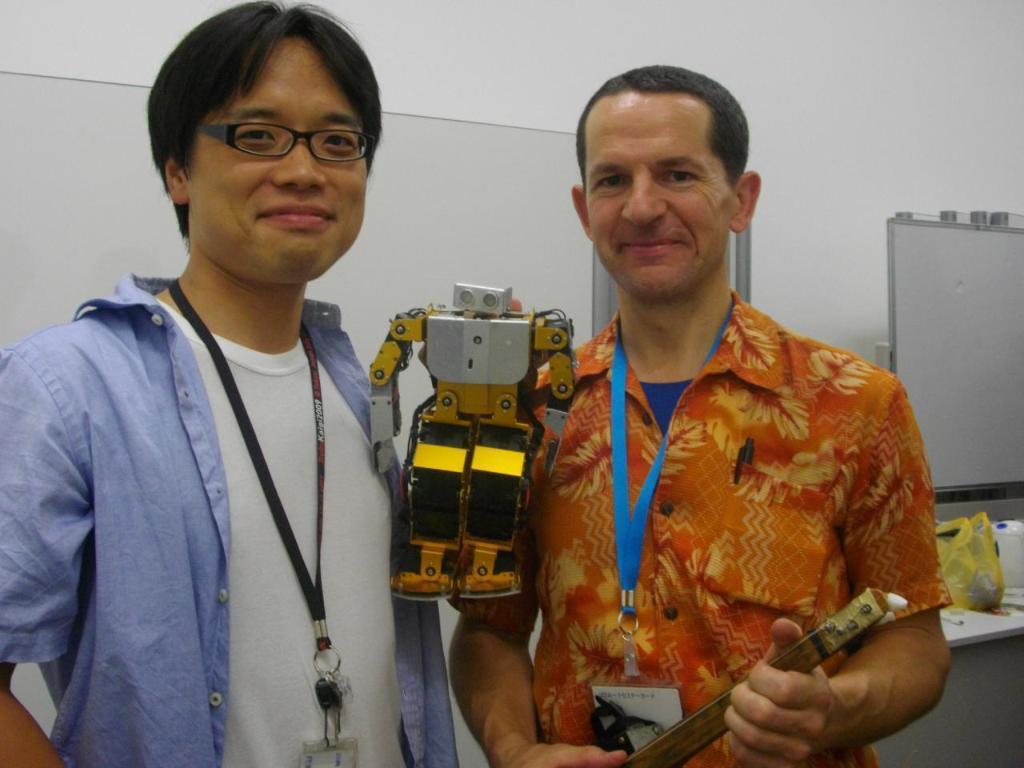How would you summarize this image in a sentence or two? In this picture we can see two men wore id cards and standing, holding toys with their hands, smiling and at the back of them we can see a plastic cover, pens and some objects on a table, boards and the wall. 